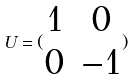<formula> <loc_0><loc_0><loc_500><loc_500>U = ( \begin{matrix} 1 & 0 \\ 0 & - 1 \end{matrix} )</formula> 